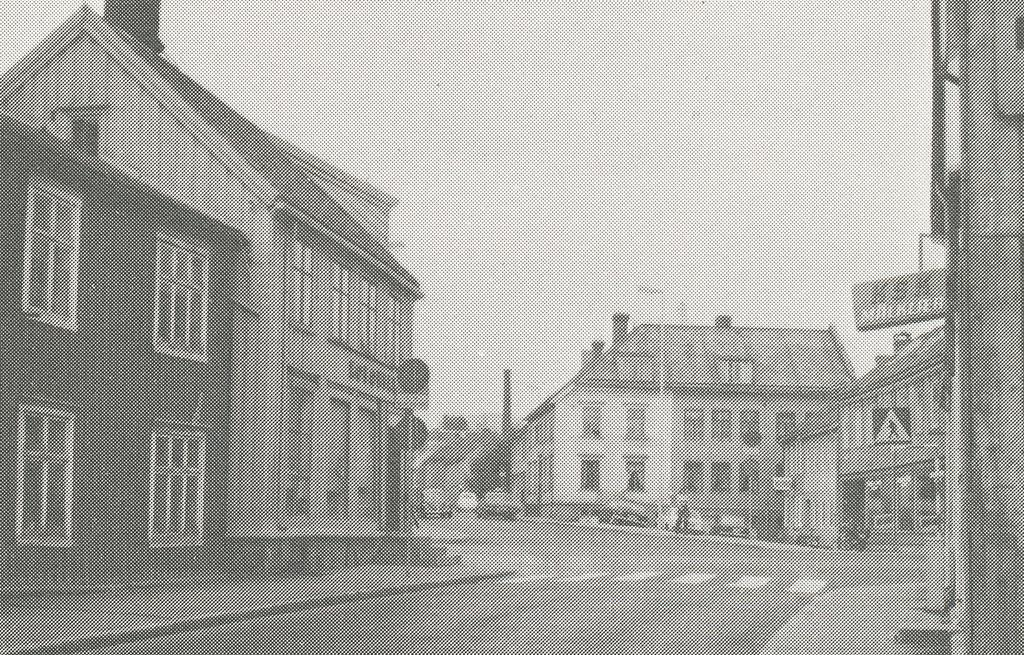<image>
Provide a brief description of the given image. Old photograph of a town and a sign on a building that says "milkier". 